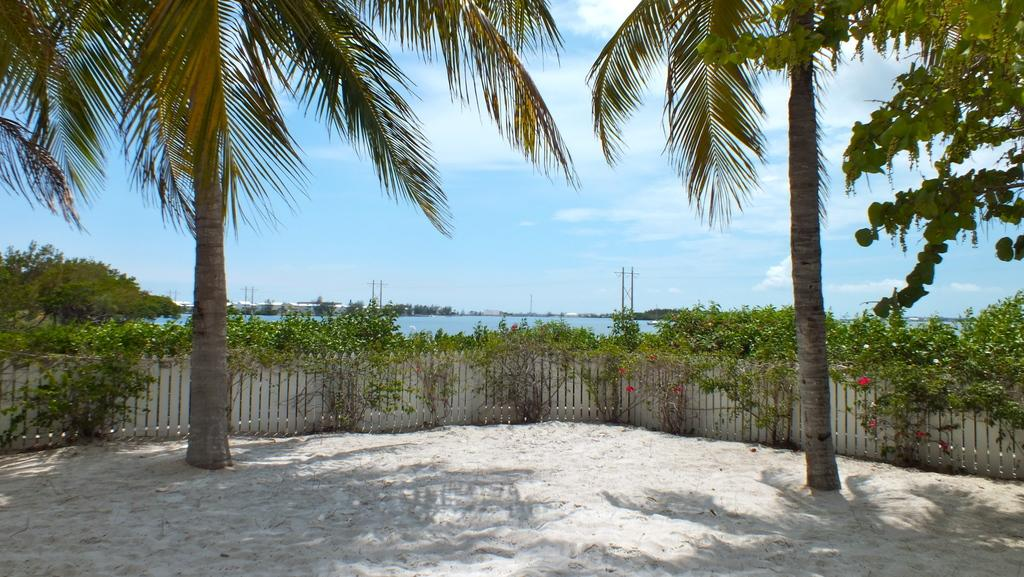What type of vegetation is present in the image? There are many trees and plants in the image. What type of fencing can be seen in the image? There is wooden fencing in the image. What is visible at the bottom of the image? There is sand visible at the bottom of the image. What can be seen in the background of the image? There is water, poles, and the sky visible in the background of the image. What type of steel sheet can be seen in the image? There is no steel sheet present in the image. How many fingers are visible in the image? There are no fingers visible in the image. 